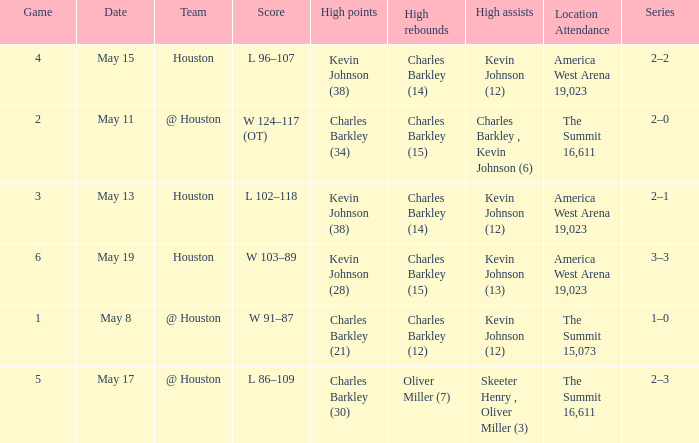In what series did Charles Barkley (34) did most high points? 2–0. 